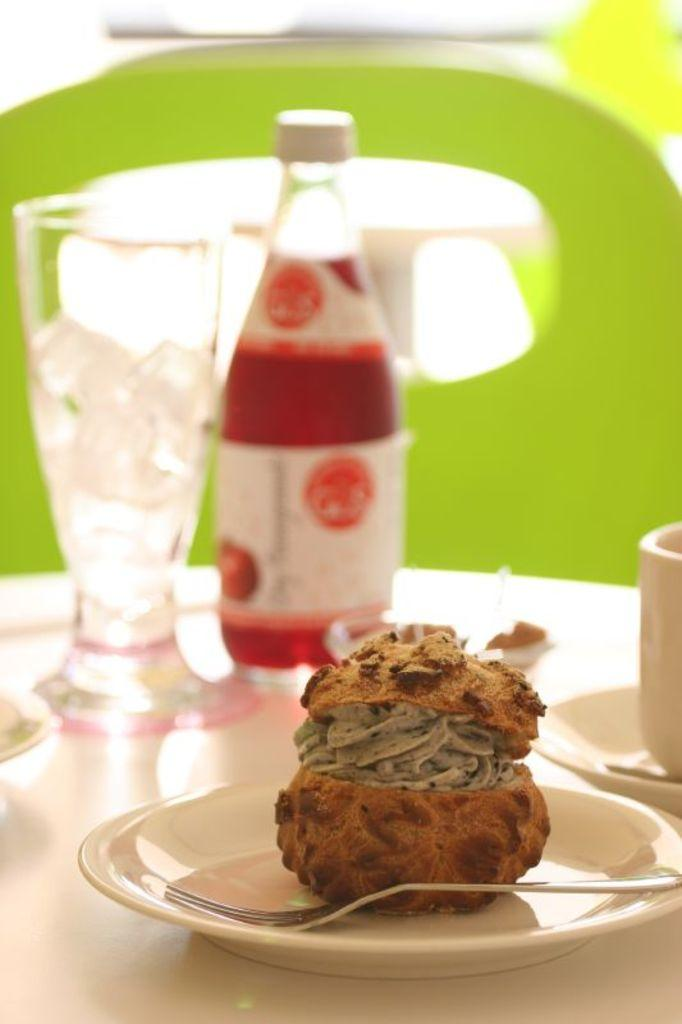What is on the plate in the image? There is a food item on a plate in the image. What utensil is present in the image? There is a fork in the image. What type of container is visible in the image? There is a bottle in the image. What type of drinking vessel is present in the image? There is a glass in the image. What type of beverage container is present in the image? There is a tea cup in the image. What is the tax rate on the food item in the image? There is no information about tax rates in the image, as it only shows a food item on a plate, a fork, a bottle, a glass, and a tea cup. 